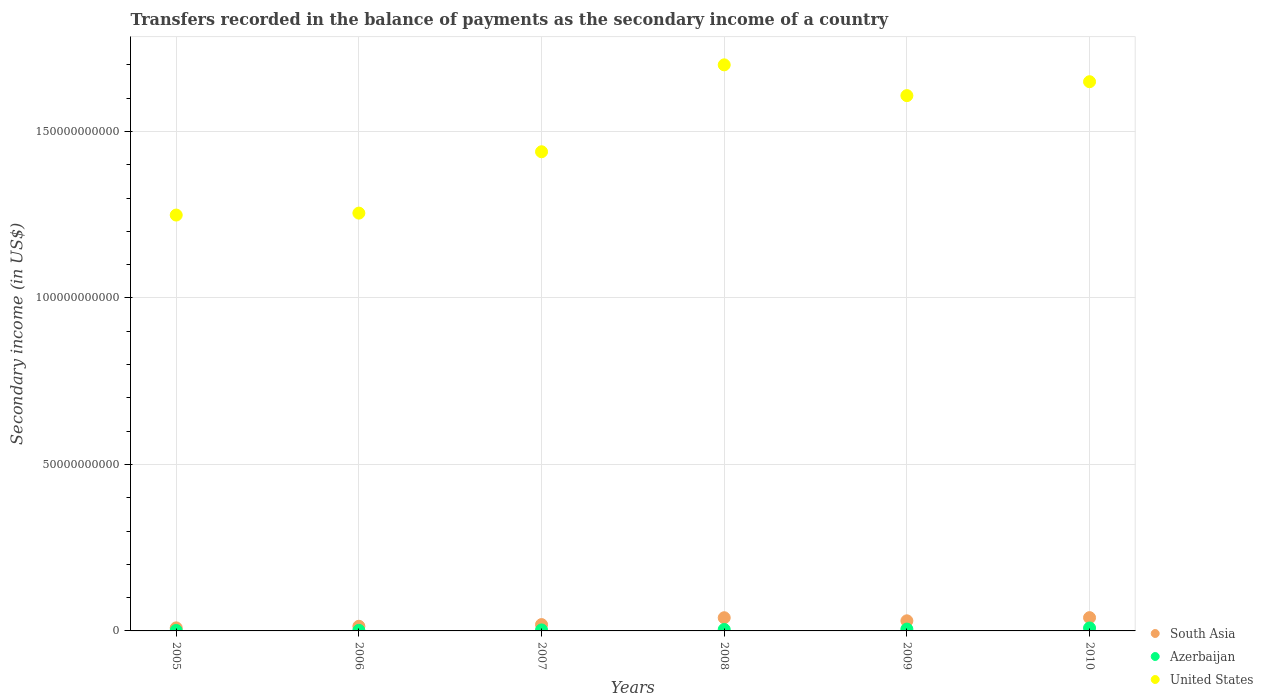How many different coloured dotlines are there?
Make the answer very short. 3. Is the number of dotlines equal to the number of legend labels?
Provide a succinct answer. Yes. What is the secondary income of in South Asia in 2010?
Ensure brevity in your answer.  3.98e+09. Across all years, what is the maximum secondary income of in Azerbaijan?
Keep it short and to the point. 8.79e+08. Across all years, what is the minimum secondary income of in Azerbaijan?
Provide a succinct answer. 1.35e+08. What is the total secondary income of in Azerbaijan in the graph?
Give a very brief answer. 2.47e+09. What is the difference between the secondary income of in South Asia in 2006 and that in 2008?
Offer a terse response. -2.57e+09. What is the difference between the secondary income of in South Asia in 2005 and the secondary income of in Azerbaijan in 2009?
Your response must be concise. 3.66e+08. What is the average secondary income of in Azerbaijan per year?
Give a very brief answer. 4.12e+08. In the year 2010, what is the difference between the secondary income of in South Asia and secondary income of in Azerbaijan?
Offer a terse response. 3.11e+09. In how many years, is the secondary income of in South Asia greater than 80000000000 US$?
Make the answer very short. 0. What is the ratio of the secondary income of in Azerbaijan in 2008 to that in 2010?
Give a very brief answer. 0.49. Is the secondary income of in United States in 2008 less than that in 2010?
Provide a short and direct response. No. What is the difference between the highest and the second highest secondary income of in United States?
Your answer should be very brief. 5.06e+09. What is the difference between the highest and the lowest secondary income of in Azerbaijan?
Ensure brevity in your answer.  7.44e+08. In how many years, is the secondary income of in Azerbaijan greater than the average secondary income of in Azerbaijan taken over all years?
Your answer should be compact. 3. Is it the case that in every year, the sum of the secondary income of in Azerbaijan and secondary income of in South Asia  is greater than the secondary income of in United States?
Provide a succinct answer. No. Does the secondary income of in United States monotonically increase over the years?
Your answer should be very brief. No. Is the secondary income of in South Asia strictly less than the secondary income of in United States over the years?
Provide a short and direct response. Yes. How many dotlines are there?
Your response must be concise. 3. What is the difference between two consecutive major ticks on the Y-axis?
Provide a short and direct response. 5.00e+1. Are the values on the major ticks of Y-axis written in scientific E-notation?
Provide a short and direct response. No. Does the graph contain any zero values?
Offer a very short reply. No. Where does the legend appear in the graph?
Ensure brevity in your answer.  Bottom right. How many legend labels are there?
Provide a short and direct response. 3. How are the legend labels stacked?
Your answer should be compact. Vertical. What is the title of the graph?
Ensure brevity in your answer.  Transfers recorded in the balance of payments as the secondary income of a country. What is the label or title of the X-axis?
Your answer should be very brief. Years. What is the label or title of the Y-axis?
Offer a terse response. Secondary income (in US$). What is the Secondary income (in US$) of South Asia in 2005?
Offer a terse response. 9.16e+08. What is the Secondary income (in US$) of Azerbaijan in 2005?
Give a very brief answer. 1.35e+08. What is the Secondary income (in US$) of United States in 2005?
Offer a terse response. 1.25e+11. What is the Secondary income (in US$) in South Asia in 2006?
Provide a succinct answer. 1.40e+09. What is the Secondary income (in US$) of Azerbaijan in 2006?
Offer a terse response. 1.75e+08. What is the Secondary income (in US$) in United States in 2006?
Your response must be concise. 1.25e+11. What is the Secondary income (in US$) in South Asia in 2007?
Offer a very short reply. 1.90e+09. What is the Secondary income (in US$) in Azerbaijan in 2007?
Keep it short and to the point. 2.99e+08. What is the Secondary income (in US$) of United States in 2007?
Provide a succinct answer. 1.44e+11. What is the Secondary income (in US$) in South Asia in 2008?
Offer a very short reply. 3.96e+09. What is the Secondary income (in US$) in Azerbaijan in 2008?
Ensure brevity in your answer.  4.33e+08. What is the Secondary income (in US$) of United States in 2008?
Make the answer very short. 1.70e+11. What is the Secondary income (in US$) of South Asia in 2009?
Provide a succinct answer. 3.04e+09. What is the Secondary income (in US$) in Azerbaijan in 2009?
Keep it short and to the point. 5.50e+08. What is the Secondary income (in US$) in United States in 2009?
Ensure brevity in your answer.  1.61e+11. What is the Secondary income (in US$) in South Asia in 2010?
Ensure brevity in your answer.  3.98e+09. What is the Secondary income (in US$) of Azerbaijan in 2010?
Provide a succinct answer. 8.79e+08. What is the Secondary income (in US$) in United States in 2010?
Make the answer very short. 1.65e+11. Across all years, what is the maximum Secondary income (in US$) in South Asia?
Provide a short and direct response. 3.98e+09. Across all years, what is the maximum Secondary income (in US$) in Azerbaijan?
Ensure brevity in your answer.  8.79e+08. Across all years, what is the maximum Secondary income (in US$) in United States?
Give a very brief answer. 1.70e+11. Across all years, what is the minimum Secondary income (in US$) of South Asia?
Your answer should be very brief. 9.16e+08. Across all years, what is the minimum Secondary income (in US$) of Azerbaijan?
Keep it short and to the point. 1.35e+08. Across all years, what is the minimum Secondary income (in US$) of United States?
Keep it short and to the point. 1.25e+11. What is the total Secondary income (in US$) in South Asia in the graph?
Keep it short and to the point. 1.52e+1. What is the total Secondary income (in US$) of Azerbaijan in the graph?
Make the answer very short. 2.47e+09. What is the total Secondary income (in US$) in United States in the graph?
Offer a terse response. 8.90e+11. What is the difference between the Secondary income (in US$) in South Asia in 2005 and that in 2006?
Give a very brief answer. -4.79e+08. What is the difference between the Secondary income (in US$) in Azerbaijan in 2005 and that in 2006?
Make the answer very short. -3.98e+07. What is the difference between the Secondary income (in US$) of United States in 2005 and that in 2006?
Ensure brevity in your answer.  -5.83e+08. What is the difference between the Secondary income (in US$) in South Asia in 2005 and that in 2007?
Offer a very short reply. -9.88e+08. What is the difference between the Secondary income (in US$) of Azerbaijan in 2005 and that in 2007?
Your answer should be compact. -1.64e+08. What is the difference between the Secondary income (in US$) of United States in 2005 and that in 2007?
Keep it short and to the point. -1.90e+1. What is the difference between the Secondary income (in US$) of South Asia in 2005 and that in 2008?
Provide a short and direct response. -3.04e+09. What is the difference between the Secondary income (in US$) in Azerbaijan in 2005 and that in 2008?
Provide a succinct answer. -2.98e+08. What is the difference between the Secondary income (in US$) of United States in 2005 and that in 2008?
Offer a very short reply. -4.51e+1. What is the difference between the Secondary income (in US$) in South Asia in 2005 and that in 2009?
Your response must be concise. -2.12e+09. What is the difference between the Secondary income (in US$) in Azerbaijan in 2005 and that in 2009?
Offer a terse response. -4.15e+08. What is the difference between the Secondary income (in US$) of United States in 2005 and that in 2009?
Your answer should be very brief. -3.59e+1. What is the difference between the Secondary income (in US$) in South Asia in 2005 and that in 2010?
Provide a short and direct response. -3.07e+09. What is the difference between the Secondary income (in US$) in Azerbaijan in 2005 and that in 2010?
Make the answer very short. -7.44e+08. What is the difference between the Secondary income (in US$) of United States in 2005 and that in 2010?
Provide a succinct answer. -4.00e+1. What is the difference between the Secondary income (in US$) in South Asia in 2006 and that in 2007?
Keep it short and to the point. -5.09e+08. What is the difference between the Secondary income (in US$) in Azerbaijan in 2006 and that in 2007?
Keep it short and to the point. -1.25e+08. What is the difference between the Secondary income (in US$) of United States in 2006 and that in 2007?
Keep it short and to the point. -1.84e+1. What is the difference between the Secondary income (in US$) of South Asia in 2006 and that in 2008?
Offer a terse response. -2.57e+09. What is the difference between the Secondary income (in US$) of Azerbaijan in 2006 and that in 2008?
Offer a terse response. -2.59e+08. What is the difference between the Secondary income (in US$) of United States in 2006 and that in 2008?
Your answer should be compact. -4.45e+1. What is the difference between the Secondary income (in US$) in South Asia in 2006 and that in 2009?
Offer a very short reply. -1.64e+09. What is the difference between the Secondary income (in US$) of Azerbaijan in 2006 and that in 2009?
Provide a succinct answer. -3.76e+08. What is the difference between the Secondary income (in US$) in United States in 2006 and that in 2009?
Make the answer very short. -3.53e+1. What is the difference between the Secondary income (in US$) of South Asia in 2006 and that in 2010?
Ensure brevity in your answer.  -2.59e+09. What is the difference between the Secondary income (in US$) in Azerbaijan in 2006 and that in 2010?
Give a very brief answer. -7.05e+08. What is the difference between the Secondary income (in US$) of United States in 2006 and that in 2010?
Give a very brief answer. -3.95e+1. What is the difference between the Secondary income (in US$) in South Asia in 2007 and that in 2008?
Offer a terse response. -2.06e+09. What is the difference between the Secondary income (in US$) in Azerbaijan in 2007 and that in 2008?
Offer a very short reply. -1.34e+08. What is the difference between the Secondary income (in US$) in United States in 2007 and that in 2008?
Your answer should be very brief. -2.61e+1. What is the difference between the Secondary income (in US$) in South Asia in 2007 and that in 2009?
Give a very brief answer. -1.13e+09. What is the difference between the Secondary income (in US$) in Azerbaijan in 2007 and that in 2009?
Provide a succinct answer. -2.51e+08. What is the difference between the Secondary income (in US$) of United States in 2007 and that in 2009?
Offer a terse response. -1.69e+1. What is the difference between the Secondary income (in US$) in South Asia in 2007 and that in 2010?
Your answer should be very brief. -2.08e+09. What is the difference between the Secondary income (in US$) of Azerbaijan in 2007 and that in 2010?
Keep it short and to the point. -5.80e+08. What is the difference between the Secondary income (in US$) of United States in 2007 and that in 2010?
Offer a very short reply. -2.10e+1. What is the difference between the Secondary income (in US$) in South Asia in 2008 and that in 2009?
Provide a succinct answer. 9.25e+08. What is the difference between the Secondary income (in US$) in Azerbaijan in 2008 and that in 2009?
Provide a succinct answer. -1.17e+08. What is the difference between the Secondary income (in US$) in United States in 2008 and that in 2009?
Ensure brevity in your answer.  9.24e+09. What is the difference between the Secondary income (in US$) in South Asia in 2008 and that in 2010?
Provide a succinct answer. -2.42e+07. What is the difference between the Secondary income (in US$) of Azerbaijan in 2008 and that in 2010?
Give a very brief answer. -4.46e+08. What is the difference between the Secondary income (in US$) of United States in 2008 and that in 2010?
Give a very brief answer. 5.06e+09. What is the difference between the Secondary income (in US$) of South Asia in 2009 and that in 2010?
Your response must be concise. -9.49e+08. What is the difference between the Secondary income (in US$) of Azerbaijan in 2009 and that in 2010?
Keep it short and to the point. -3.29e+08. What is the difference between the Secondary income (in US$) of United States in 2009 and that in 2010?
Ensure brevity in your answer.  -4.17e+09. What is the difference between the Secondary income (in US$) of South Asia in 2005 and the Secondary income (in US$) of Azerbaijan in 2006?
Your response must be concise. 7.42e+08. What is the difference between the Secondary income (in US$) of South Asia in 2005 and the Secondary income (in US$) of United States in 2006?
Provide a succinct answer. -1.25e+11. What is the difference between the Secondary income (in US$) in Azerbaijan in 2005 and the Secondary income (in US$) in United States in 2006?
Offer a terse response. -1.25e+11. What is the difference between the Secondary income (in US$) in South Asia in 2005 and the Secondary income (in US$) in Azerbaijan in 2007?
Your answer should be very brief. 6.17e+08. What is the difference between the Secondary income (in US$) of South Asia in 2005 and the Secondary income (in US$) of United States in 2007?
Your response must be concise. -1.43e+11. What is the difference between the Secondary income (in US$) in Azerbaijan in 2005 and the Secondary income (in US$) in United States in 2007?
Offer a terse response. -1.44e+11. What is the difference between the Secondary income (in US$) of South Asia in 2005 and the Secondary income (in US$) of Azerbaijan in 2008?
Ensure brevity in your answer.  4.83e+08. What is the difference between the Secondary income (in US$) in South Asia in 2005 and the Secondary income (in US$) in United States in 2008?
Ensure brevity in your answer.  -1.69e+11. What is the difference between the Secondary income (in US$) of Azerbaijan in 2005 and the Secondary income (in US$) of United States in 2008?
Your answer should be compact. -1.70e+11. What is the difference between the Secondary income (in US$) in South Asia in 2005 and the Secondary income (in US$) in Azerbaijan in 2009?
Offer a very short reply. 3.66e+08. What is the difference between the Secondary income (in US$) of South Asia in 2005 and the Secondary income (in US$) of United States in 2009?
Offer a terse response. -1.60e+11. What is the difference between the Secondary income (in US$) in Azerbaijan in 2005 and the Secondary income (in US$) in United States in 2009?
Provide a short and direct response. -1.61e+11. What is the difference between the Secondary income (in US$) in South Asia in 2005 and the Secondary income (in US$) in Azerbaijan in 2010?
Ensure brevity in your answer.  3.69e+07. What is the difference between the Secondary income (in US$) in South Asia in 2005 and the Secondary income (in US$) in United States in 2010?
Give a very brief answer. -1.64e+11. What is the difference between the Secondary income (in US$) in Azerbaijan in 2005 and the Secondary income (in US$) in United States in 2010?
Your answer should be very brief. -1.65e+11. What is the difference between the Secondary income (in US$) of South Asia in 2006 and the Secondary income (in US$) of Azerbaijan in 2007?
Your answer should be very brief. 1.10e+09. What is the difference between the Secondary income (in US$) of South Asia in 2006 and the Secondary income (in US$) of United States in 2007?
Give a very brief answer. -1.42e+11. What is the difference between the Secondary income (in US$) in Azerbaijan in 2006 and the Secondary income (in US$) in United States in 2007?
Offer a very short reply. -1.44e+11. What is the difference between the Secondary income (in US$) of South Asia in 2006 and the Secondary income (in US$) of Azerbaijan in 2008?
Provide a short and direct response. 9.62e+08. What is the difference between the Secondary income (in US$) of South Asia in 2006 and the Secondary income (in US$) of United States in 2008?
Provide a short and direct response. -1.69e+11. What is the difference between the Secondary income (in US$) in Azerbaijan in 2006 and the Secondary income (in US$) in United States in 2008?
Your answer should be compact. -1.70e+11. What is the difference between the Secondary income (in US$) of South Asia in 2006 and the Secondary income (in US$) of Azerbaijan in 2009?
Ensure brevity in your answer.  8.45e+08. What is the difference between the Secondary income (in US$) of South Asia in 2006 and the Secondary income (in US$) of United States in 2009?
Your answer should be compact. -1.59e+11. What is the difference between the Secondary income (in US$) in Azerbaijan in 2006 and the Secondary income (in US$) in United States in 2009?
Give a very brief answer. -1.61e+11. What is the difference between the Secondary income (in US$) in South Asia in 2006 and the Secondary income (in US$) in Azerbaijan in 2010?
Provide a short and direct response. 5.16e+08. What is the difference between the Secondary income (in US$) of South Asia in 2006 and the Secondary income (in US$) of United States in 2010?
Make the answer very short. -1.64e+11. What is the difference between the Secondary income (in US$) of Azerbaijan in 2006 and the Secondary income (in US$) of United States in 2010?
Provide a succinct answer. -1.65e+11. What is the difference between the Secondary income (in US$) of South Asia in 2007 and the Secondary income (in US$) of Azerbaijan in 2008?
Keep it short and to the point. 1.47e+09. What is the difference between the Secondary income (in US$) in South Asia in 2007 and the Secondary income (in US$) in United States in 2008?
Your answer should be compact. -1.68e+11. What is the difference between the Secondary income (in US$) of Azerbaijan in 2007 and the Secondary income (in US$) of United States in 2008?
Offer a very short reply. -1.70e+11. What is the difference between the Secondary income (in US$) of South Asia in 2007 and the Secondary income (in US$) of Azerbaijan in 2009?
Offer a very short reply. 1.35e+09. What is the difference between the Secondary income (in US$) of South Asia in 2007 and the Secondary income (in US$) of United States in 2009?
Make the answer very short. -1.59e+11. What is the difference between the Secondary income (in US$) in Azerbaijan in 2007 and the Secondary income (in US$) in United States in 2009?
Your answer should be compact. -1.60e+11. What is the difference between the Secondary income (in US$) in South Asia in 2007 and the Secondary income (in US$) in Azerbaijan in 2010?
Keep it short and to the point. 1.03e+09. What is the difference between the Secondary income (in US$) in South Asia in 2007 and the Secondary income (in US$) in United States in 2010?
Offer a terse response. -1.63e+11. What is the difference between the Secondary income (in US$) of Azerbaijan in 2007 and the Secondary income (in US$) of United States in 2010?
Your response must be concise. -1.65e+11. What is the difference between the Secondary income (in US$) of South Asia in 2008 and the Secondary income (in US$) of Azerbaijan in 2009?
Make the answer very short. 3.41e+09. What is the difference between the Secondary income (in US$) of South Asia in 2008 and the Secondary income (in US$) of United States in 2009?
Offer a very short reply. -1.57e+11. What is the difference between the Secondary income (in US$) in Azerbaijan in 2008 and the Secondary income (in US$) in United States in 2009?
Your response must be concise. -1.60e+11. What is the difference between the Secondary income (in US$) in South Asia in 2008 and the Secondary income (in US$) in Azerbaijan in 2010?
Your response must be concise. 3.08e+09. What is the difference between the Secondary income (in US$) of South Asia in 2008 and the Secondary income (in US$) of United States in 2010?
Offer a very short reply. -1.61e+11. What is the difference between the Secondary income (in US$) of Azerbaijan in 2008 and the Secondary income (in US$) of United States in 2010?
Give a very brief answer. -1.64e+11. What is the difference between the Secondary income (in US$) in South Asia in 2009 and the Secondary income (in US$) in Azerbaijan in 2010?
Give a very brief answer. 2.16e+09. What is the difference between the Secondary income (in US$) in South Asia in 2009 and the Secondary income (in US$) in United States in 2010?
Your response must be concise. -1.62e+11. What is the difference between the Secondary income (in US$) in Azerbaijan in 2009 and the Secondary income (in US$) in United States in 2010?
Provide a succinct answer. -1.64e+11. What is the average Secondary income (in US$) in South Asia per year?
Ensure brevity in your answer.  2.53e+09. What is the average Secondary income (in US$) of Azerbaijan per year?
Provide a short and direct response. 4.12e+08. What is the average Secondary income (in US$) in United States per year?
Offer a terse response. 1.48e+11. In the year 2005, what is the difference between the Secondary income (in US$) in South Asia and Secondary income (in US$) in Azerbaijan?
Your answer should be compact. 7.81e+08. In the year 2005, what is the difference between the Secondary income (in US$) of South Asia and Secondary income (in US$) of United States?
Ensure brevity in your answer.  -1.24e+11. In the year 2005, what is the difference between the Secondary income (in US$) in Azerbaijan and Secondary income (in US$) in United States?
Offer a terse response. -1.25e+11. In the year 2006, what is the difference between the Secondary income (in US$) of South Asia and Secondary income (in US$) of Azerbaijan?
Offer a very short reply. 1.22e+09. In the year 2006, what is the difference between the Secondary income (in US$) in South Asia and Secondary income (in US$) in United States?
Provide a short and direct response. -1.24e+11. In the year 2006, what is the difference between the Secondary income (in US$) of Azerbaijan and Secondary income (in US$) of United States?
Your response must be concise. -1.25e+11. In the year 2007, what is the difference between the Secondary income (in US$) in South Asia and Secondary income (in US$) in Azerbaijan?
Offer a very short reply. 1.61e+09. In the year 2007, what is the difference between the Secondary income (in US$) of South Asia and Secondary income (in US$) of United States?
Your answer should be very brief. -1.42e+11. In the year 2007, what is the difference between the Secondary income (in US$) of Azerbaijan and Secondary income (in US$) of United States?
Keep it short and to the point. -1.44e+11. In the year 2008, what is the difference between the Secondary income (in US$) of South Asia and Secondary income (in US$) of Azerbaijan?
Offer a very short reply. 3.53e+09. In the year 2008, what is the difference between the Secondary income (in US$) of South Asia and Secondary income (in US$) of United States?
Your answer should be compact. -1.66e+11. In the year 2008, what is the difference between the Secondary income (in US$) of Azerbaijan and Secondary income (in US$) of United States?
Your answer should be compact. -1.70e+11. In the year 2009, what is the difference between the Secondary income (in US$) in South Asia and Secondary income (in US$) in Azerbaijan?
Give a very brief answer. 2.49e+09. In the year 2009, what is the difference between the Secondary income (in US$) in South Asia and Secondary income (in US$) in United States?
Ensure brevity in your answer.  -1.58e+11. In the year 2009, what is the difference between the Secondary income (in US$) of Azerbaijan and Secondary income (in US$) of United States?
Your answer should be compact. -1.60e+11. In the year 2010, what is the difference between the Secondary income (in US$) of South Asia and Secondary income (in US$) of Azerbaijan?
Ensure brevity in your answer.  3.11e+09. In the year 2010, what is the difference between the Secondary income (in US$) in South Asia and Secondary income (in US$) in United States?
Provide a short and direct response. -1.61e+11. In the year 2010, what is the difference between the Secondary income (in US$) in Azerbaijan and Secondary income (in US$) in United States?
Offer a terse response. -1.64e+11. What is the ratio of the Secondary income (in US$) of South Asia in 2005 to that in 2006?
Provide a short and direct response. 0.66. What is the ratio of the Secondary income (in US$) of Azerbaijan in 2005 to that in 2006?
Ensure brevity in your answer.  0.77. What is the ratio of the Secondary income (in US$) of South Asia in 2005 to that in 2007?
Provide a succinct answer. 0.48. What is the ratio of the Secondary income (in US$) of Azerbaijan in 2005 to that in 2007?
Ensure brevity in your answer.  0.45. What is the ratio of the Secondary income (in US$) in United States in 2005 to that in 2007?
Your answer should be compact. 0.87. What is the ratio of the Secondary income (in US$) of South Asia in 2005 to that in 2008?
Keep it short and to the point. 0.23. What is the ratio of the Secondary income (in US$) in Azerbaijan in 2005 to that in 2008?
Ensure brevity in your answer.  0.31. What is the ratio of the Secondary income (in US$) of United States in 2005 to that in 2008?
Give a very brief answer. 0.73. What is the ratio of the Secondary income (in US$) of South Asia in 2005 to that in 2009?
Provide a short and direct response. 0.3. What is the ratio of the Secondary income (in US$) in Azerbaijan in 2005 to that in 2009?
Ensure brevity in your answer.  0.25. What is the ratio of the Secondary income (in US$) of United States in 2005 to that in 2009?
Offer a terse response. 0.78. What is the ratio of the Secondary income (in US$) of South Asia in 2005 to that in 2010?
Provide a short and direct response. 0.23. What is the ratio of the Secondary income (in US$) in Azerbaijan in 2005 to that in 2010?
Your answer should be very brief. 0.15. What is the ratio of the Secondary income (in US$) in United States in 2005 to that in 2010?
Your answer should be very brief. 0.76. What is the ratio of the Secondary income (in US$) in South Asia in 2006 to that in 2007?
Keep it short and to the point. 0.73. What is the ratio of the Secondary income (in US$) in Azerbaijan in 2006 to that in 2007?
Make the answer very short. 0.58. What is the ratio of the Secondary income (in US$) in United States in 2006 to that in 2007?
Provide a short and direct response. 0.87. What is the ratio of the Secondary income (in US$) of South Asia in 2006 to that in 2008?
Provide a succinct answer. 0.35. What is the ratio of the Secondary income (in US$) of Azerbaijan in 2006 to that in 2008?
Provide a short and direct response. 0.4. What is the ratio of the Secondary income (in US$) in United States in 2006 to that in 2008?
Give a very brief answer. 0.74. What is the ratio of the Secondary income (in US$) in South Asia in 2006 to that in 2009?
Keep it short and to the point. 0.46. What is the ratio of the Secondary income (in US$) in Azerbaijan in 2006 to that in 2009?
Ensure brevity in your answer.  0.32. What is the ratio of the Secondary income (in US$) in United States in 2006 to that in 2009?
Your response must be concise. 0.78. What is the ratio of the Secondary income (in US$) of South Asia in 2006 to that in 2010?
Keep it short and to the point. 0.35. What is the ratio of the Secondary income (in US$) in Azerbaijan in 2006 to that in 2010?
Your answer should be very brief. 0.2. What is the ratio of the Secondary income (in US$) of United States in 2006 to that in 2010?
Offer a very short reply. 0.76. What is the ratio of the Secondary income (in US$) of South Asia in 2007 to that in 2008?
Give a very brief answer. 0.48. What is the ratio of the Secondary income (in US$) of Azerbaijan in 2007 to that in 2008?
Offer a very short reply. 0.69. What is the ratio of the Secondary income (in US$) in United States in 2007 to that in 2008?
Keep it short and to the point. 0.85. What is the ratio of the Secondary income (in US$) of South Asia in 2007 to that in 2009?
Give a very brief answer. 0.63. What is the ratio of the Secondary income (in US$) of Azerbaijan in 2007 to that in 2009?
Provide a succinct answer. 0.54. What is the ratio of the Secondary income (in US$) in United States in 2007 to that in 2009?
Offer a very short reply. 0.9. What is the ratio of the Secondary income (in US$) in South Asia in 2007 to that in 2010?
Provide a short and direct response. 0.48. What is the ratio of the Secondary income (in US$) in Azerbaijan in 2007 to that in 2010?
Offer a very short reply. 0.34. What is the ratio of the Secondary income (in US$) in United States in 2007 to that in 2010?
Your response must be concise. 0.87. What is the ratio of the Secondary income (in US$) in South Asia in 2008 to that in 2009?
Provide a short and direct response. 1.3. What is the ratio of the Secondary income (in US$) of Azerbaijan in 2008 to that in 2009?
Provide a succinct answer. 0.79. What is the ratio of the Secondary income (in US$) in United States in 2008 to that in 2009?
Offer a terse response. 1.06. What is the ratio of the Secondary income (in US$) of South Asia in 2008 to that in 2010?
Provide a succinct answer. 0.99. What is the ratio of the Secondary income (in US$) of Azerbaijan in 2008 to that in 2010?
Offer a very short reply. 0.49. What is the ratio of the Secondary income (in US$) in United States in 2008 to that in 2010?
Offer a terse response. 1.03. What is the ratio of the Secondary income (in US$) in South Asia in 2009 to that in 2010?
Ensure brevity in your answer.  0.76. What is the ratio of the Secondary income (in US$) in Azerbaijan in 2009 to that in 2010?
Make the answer very short. 0.63. What is the ratio of the Secondary income (in US$) in United States in 2009 to that in 2010?
Provide a succinct answer. 0.97. What is the difference between the highest and the second highest Secondary income (in US$) of South Asia?
Ensure brevity in your answer.  2.42e+07. What is the difference between the highest and the second highest Secondary income (in US$) of Azerbaijan?
Give a very brief answer. 3.29e+08. What is the difference between the highest and the second highest Secondary income (in US$) of United States?
Keep it short and to the point. 5.06e+09. What is the difference between the highest and the lowest Secondary income (in US$) of South Asia?
Provide a short and direct response. 3.07e+09. What is the difference between the highest and the lowest Secondary income (in US$) in Azerbaijan?
Your answer should be compact. 7.44e+08. What is the difference between the highest and the lowest Secondary income (in US$) in United States?
Your answer should be very brief. 4.51e+1. 